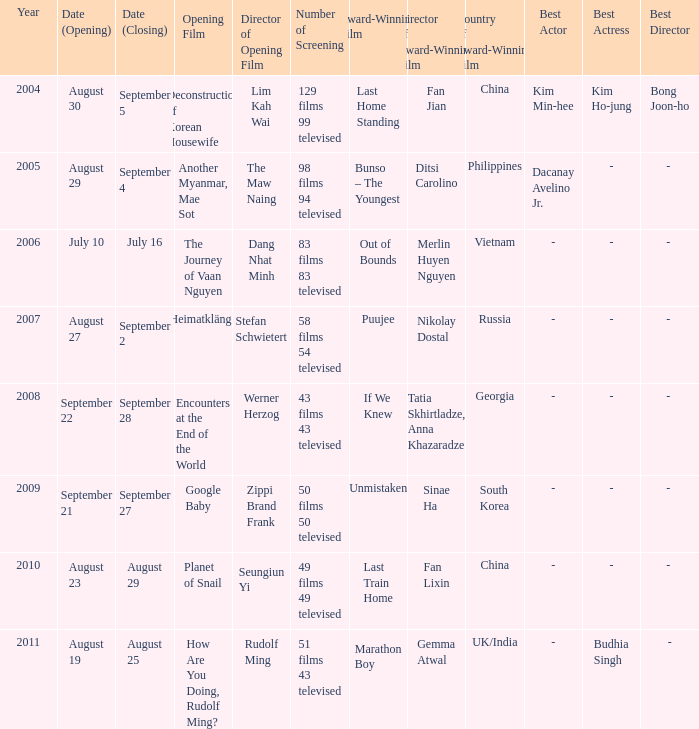Which award-winning film has a closing date of September 4? Bunso – The Youngest. Write the full table. {'header': ['Year', 'Date (Opening)', 'Date (Closing)', 'Opening Film', 'Director of Opening Film', 'Number of Screening', 'Award-Winning Film', 'Director of Award-Winning Film', 'Country of Award-Winning Film', 'Best Actor', 'Best Actress', 'Best Director'], 'rows': [['2004', 'August 30', 'September 5', 'Deconstruction of Korean Housewife', 'Lim Kah Wai', '129 films 99 televised', 'Last Home Standing', 'Fan Jian', 'China', 'Kim Min-hee', 'Kim Ho-jung', 'Bong Joon-ho'], ['2005', 'August 29', 'September 4', 'Another Myanmar, Mae Sot', 'The Maw Naing', '98 films 94 televised', 'Bunso – The Youngest', 'Ditsi Carolino', 'Philippines', 'Dacanay Avelino Jr.', '-', '- '], ['2006', 'July 10', 'July 16', 'The Journey of Vaan Nguyen', 'Dang Nhat Minh', '83 films 83 televised', 'Out of Bounds', 'Merlin Huyen Nguyen', 'Vietnam', '-', '-', '- '], ['2007', 'August 27', 'September 2', 'Heimatklänge', 'Stefan Schwietert', '58 films 54 televised', 'Puujee', 'Nikolay Dostal', 'Russia', '-', '-', '- '], ['2008', 'September 22', 'September 28', 'Encounters at the End of the World', 'Werner Herzog', '43 films 43 televised', 'If We Knew', 'Tatia Skhirtladze, Anna Khazaradze', 'Georgia', '-', '-', '- '], ['2009', 'September 21', 'September 27', 'Google Baby', 'Zippi Brand Frank', '50 films 50 televised', 'Unmistaken', 'Sinae Ha', 'South Korea', '-', '-', '- '], ['2010', 'August 23', 'August 29', 'Planet of Snail', 'Seungiun Yi', '49 films 49 televised', 'Last Train Home', 'Fan Lixin', 'China', '-', '-', '- '], ['2011', 'August 19', 'August 25', 'How Are You Doing, Rudolf Ming?', 'Rudolf Ming', '51 films 43 televised', 'Marathon Boy', 'Gemma Atwal', 'UK/India', '-', 'Budhia Singh', '-']]} 